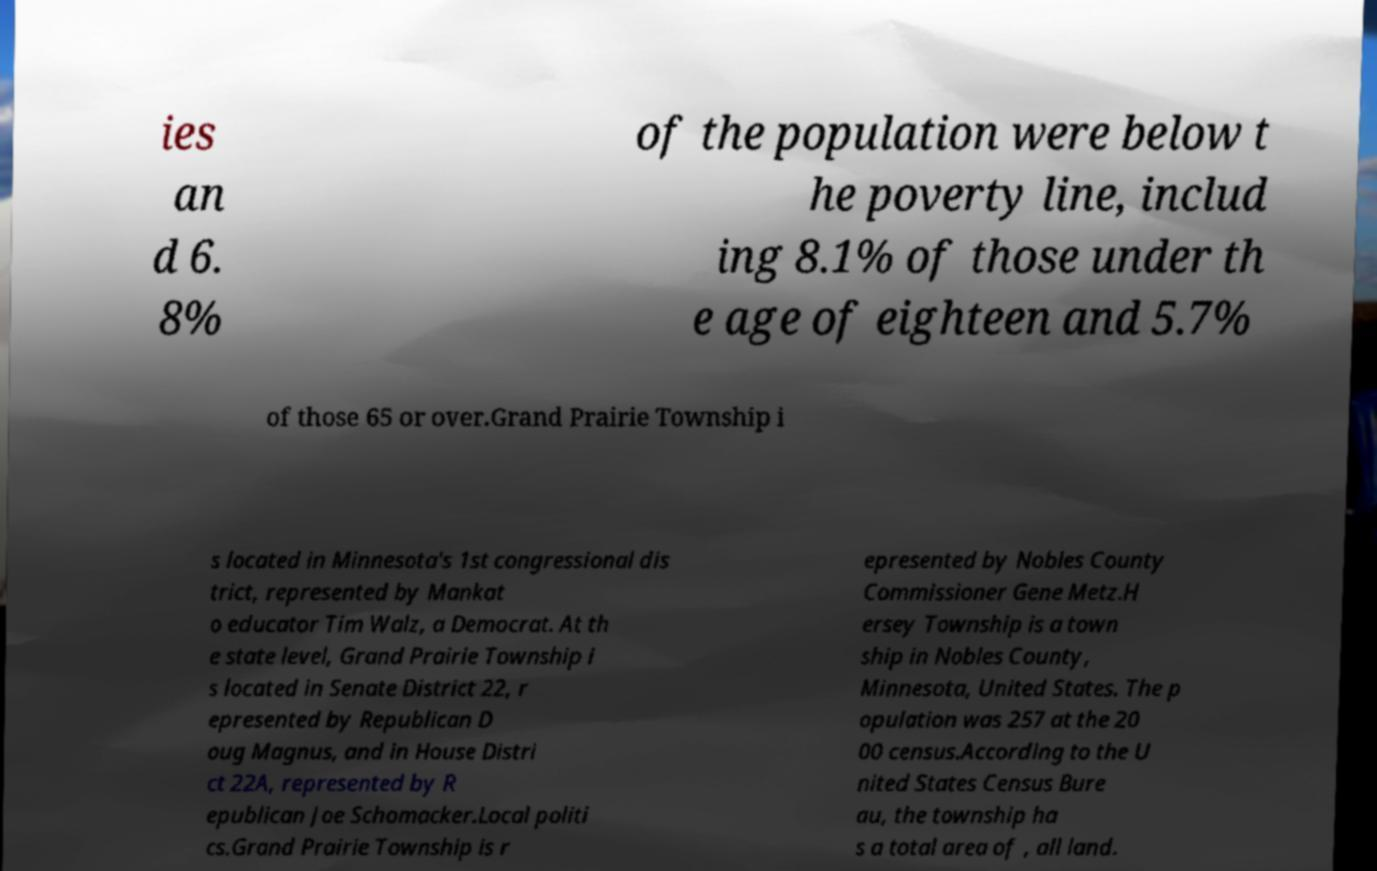Can you accurately transcribe the text from the provided image for me? ies an d 6. 8% of the population were below t he poverty line, includ ing 8.1% of those under th e age of eighteen and 5.7% of those 65 or over.Grand Prairie Township i s located in Minnesota's 1st congressional dis trict, represented by Mankat o educator Tim Walz, a Democrat. At th e state level, Grand Prairie Township i s located in Senate District 22, r epresented by Republican D oug Magnus, and in House Distri ct 22A, represented by R epublican Joe Schomacker.Local politi cs.Grand Prairie Township is r epresented by Nobles County Commissioner Gene Metz.H ersey Township is a town ship in Nobles County, Minnesota, United States. The p opulation was 257 at the 20 00 census.According to the U nited States Census Bure au, the township ha s a total area of , all land. 